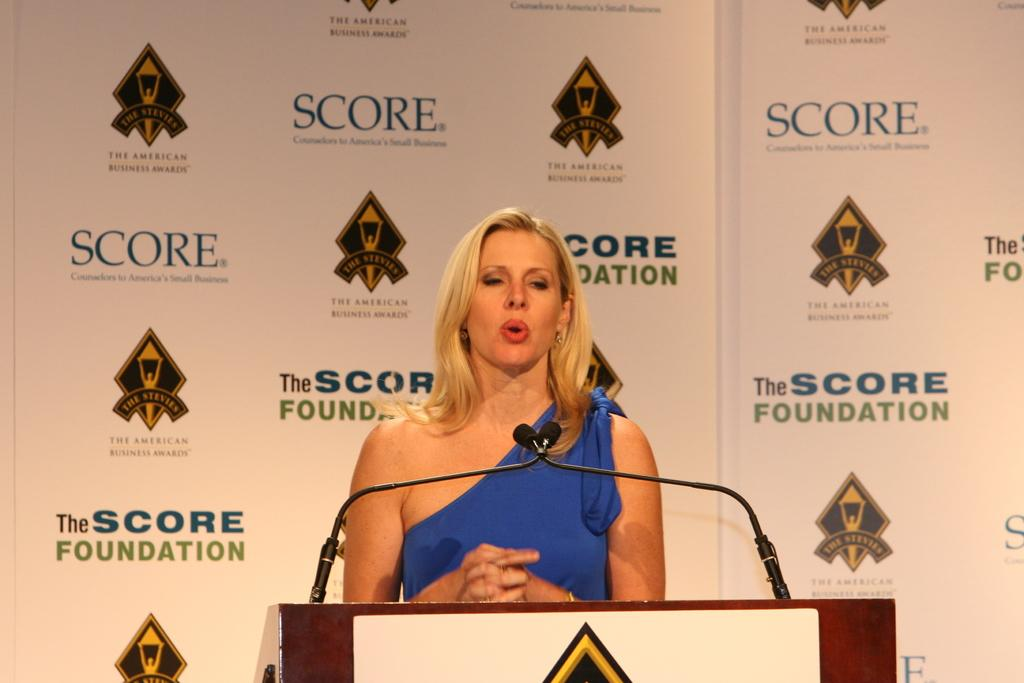Who is standing near the podium in the image? There is a woman standing near the podium in the image. What can be seen on the podium? There are two microphones on the podium. What is visible behind the podium? There is a banner behind the podium. What is written on the banner? The banner has the word "Score" written on it. What direction is the woman facing in the image? The provided facts do not mention the direction the woman is facing, so we cannot definitively answer that question. 